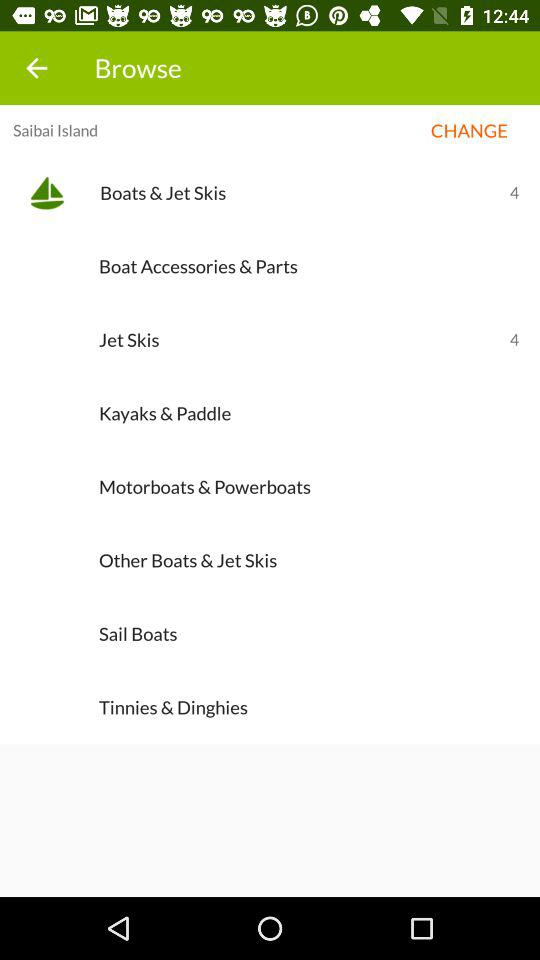What's the count for jet skis? The count for jet skis is 4. 